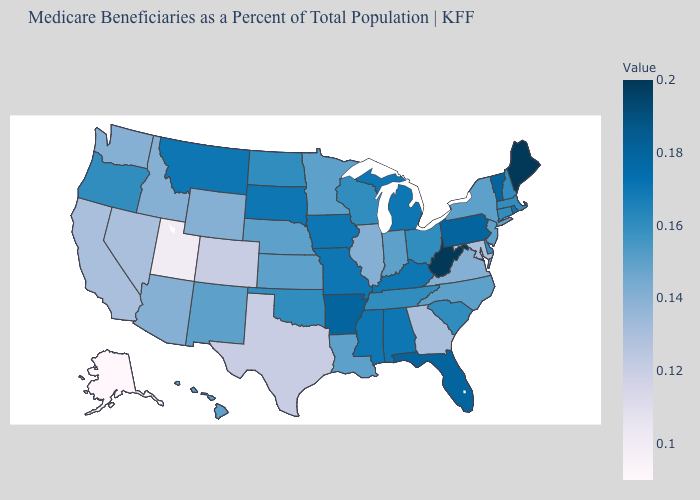Which states hav the highest value in the West?
Concise answer only. Montana. Does Alaska have the lowest value in the USA?
Write a very short answer. Yes. Among the states that border New Hampshire , which have the highest value?
Short answer required. Maine. Among the states that border Kentucky , does Illinois have the lowest value?
Be succinct. Yes. Which states hav the highest value in the MidWest?
Answer briefly. Iowa, Michigan, Missouri, South Dakota. Does the map have missing data?
Give a very brief answer. No. 